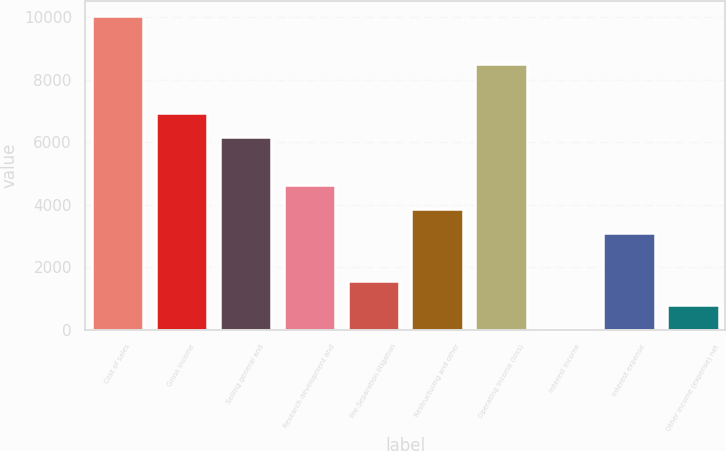Convert chart. <chart><loc_0><loc_0><loc_500><loc_500><bar_chart><fcel>Cost of sales<fcel>Gross income<fcel>Selling general and<fcel>Research development and<fcel>Pre-Separation litigation<fcel>Restructuring and other<fcel>Operating income (loss)<fcel>Interest income<fcel>Interest expense<fcel>Other income (expense) net<nl><fcel>10030.9<fcel>6949.7<fcel>6179.4<fcel>4638.8<fcel>1557.6<fcel>3868.5<fcel>8490.3<fcel>17<fcel>3098.2<fcel>787.3<nl></chart> 